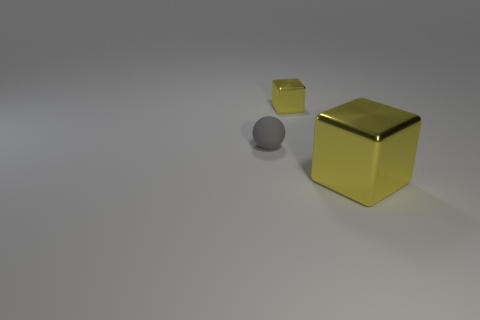What number of objects are rubber spheres or big yellow metal cubes?
Your answer should be compact. 2. Is the color of the rubber thing the same as the small metallic object?
Provide a short and direct response. No. Are there any other things that have the same size as the gray matte thing?
Your answer should be compact. Yes. What shape is the small gray object to the left of the yellow block in front of the tiny yellow object?
Make the answer very short. Sphere. Are there fewer small yellow shiny cubes than yellow metallic cylinders?
Your answer should be compact. No. There is a object that is both to the right of the gray thing and in front of the small shiny thing; what size is it?
Keep it short and to the point. Large. Do the shiny object on the right side of the small yellow metal block and the small metal block have the same color?
Give a very brief answer. Yes. How many yellow things are behind the tiny gray ball?
Give a very brief answer. 1. Is the number of yellow objects greater than the number of small rubber objects?
Keep it short and to the point. Yes. What shape is the object that is both right of the gray rubber ball and in front of the small metallic block?
Make the answer very short. Cube. 